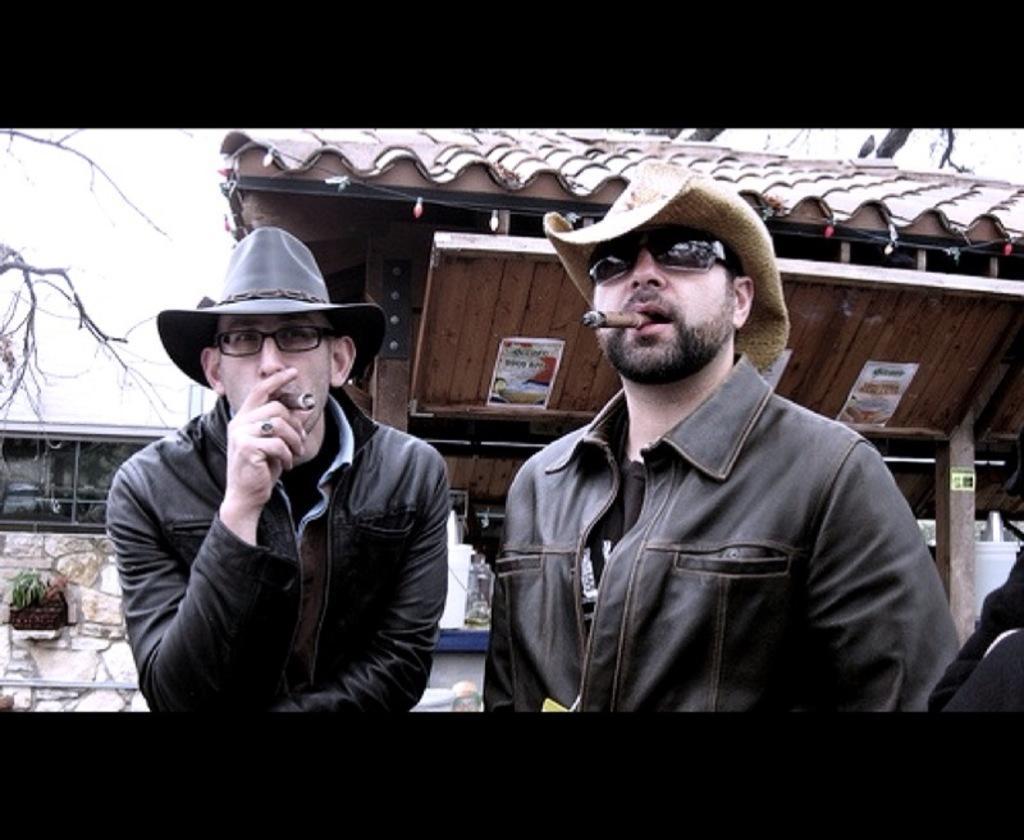Describe this image in one or two sentences. In the center of the image we can see two persons holding a cigar. In the background there is a shed, wall and tree. 